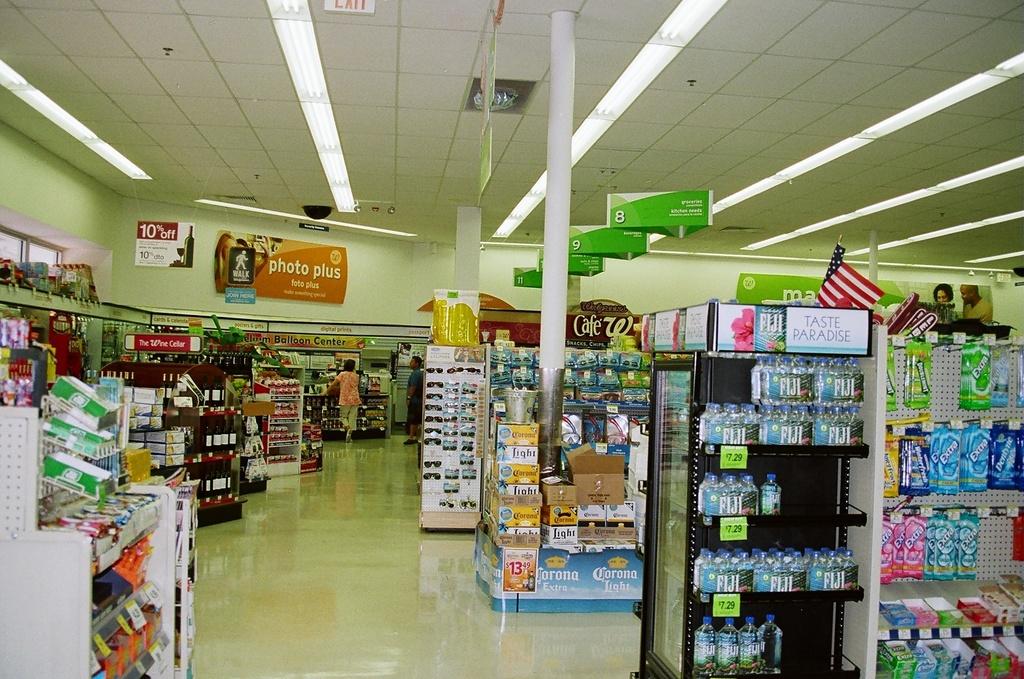What brand of water is on the shelf?
Offer a terse response. Fiji. What kind of beer is on the end of the isle?
Your answer should be very brief. Corona. 